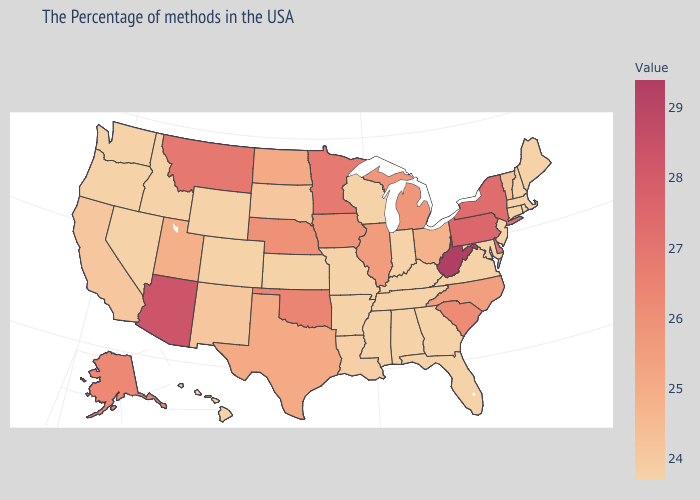Does Pennsylvania have the highest value in the Northeast?
Give a very brief answer. Yes. Among the states that border Illinois , which have the lowest value?
Concise answer only. Kentucky, Indiana, Wisconsin, Missouri. Among the states that border Pennsylvania , which have the lowest value?
Write a very short answer. New Jersey, Maryland. 